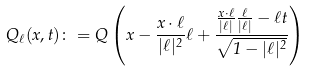Convert formula to latex. <formula><loc_0><loc_0><loc_500><loc_500>Q _ { \ell } ( x , t ) \colon = Q \left ( x - \frac { x \cdot \ell } { | \ell | ^ { 2 } } \ell + \frac { \frac { x \cdot \ell } { | \ell | } \frac { \ell } { | \ell | } - \ell t } { \sqrt { 1 - | \ell | ^ { 2 } } } \right )</formula> 